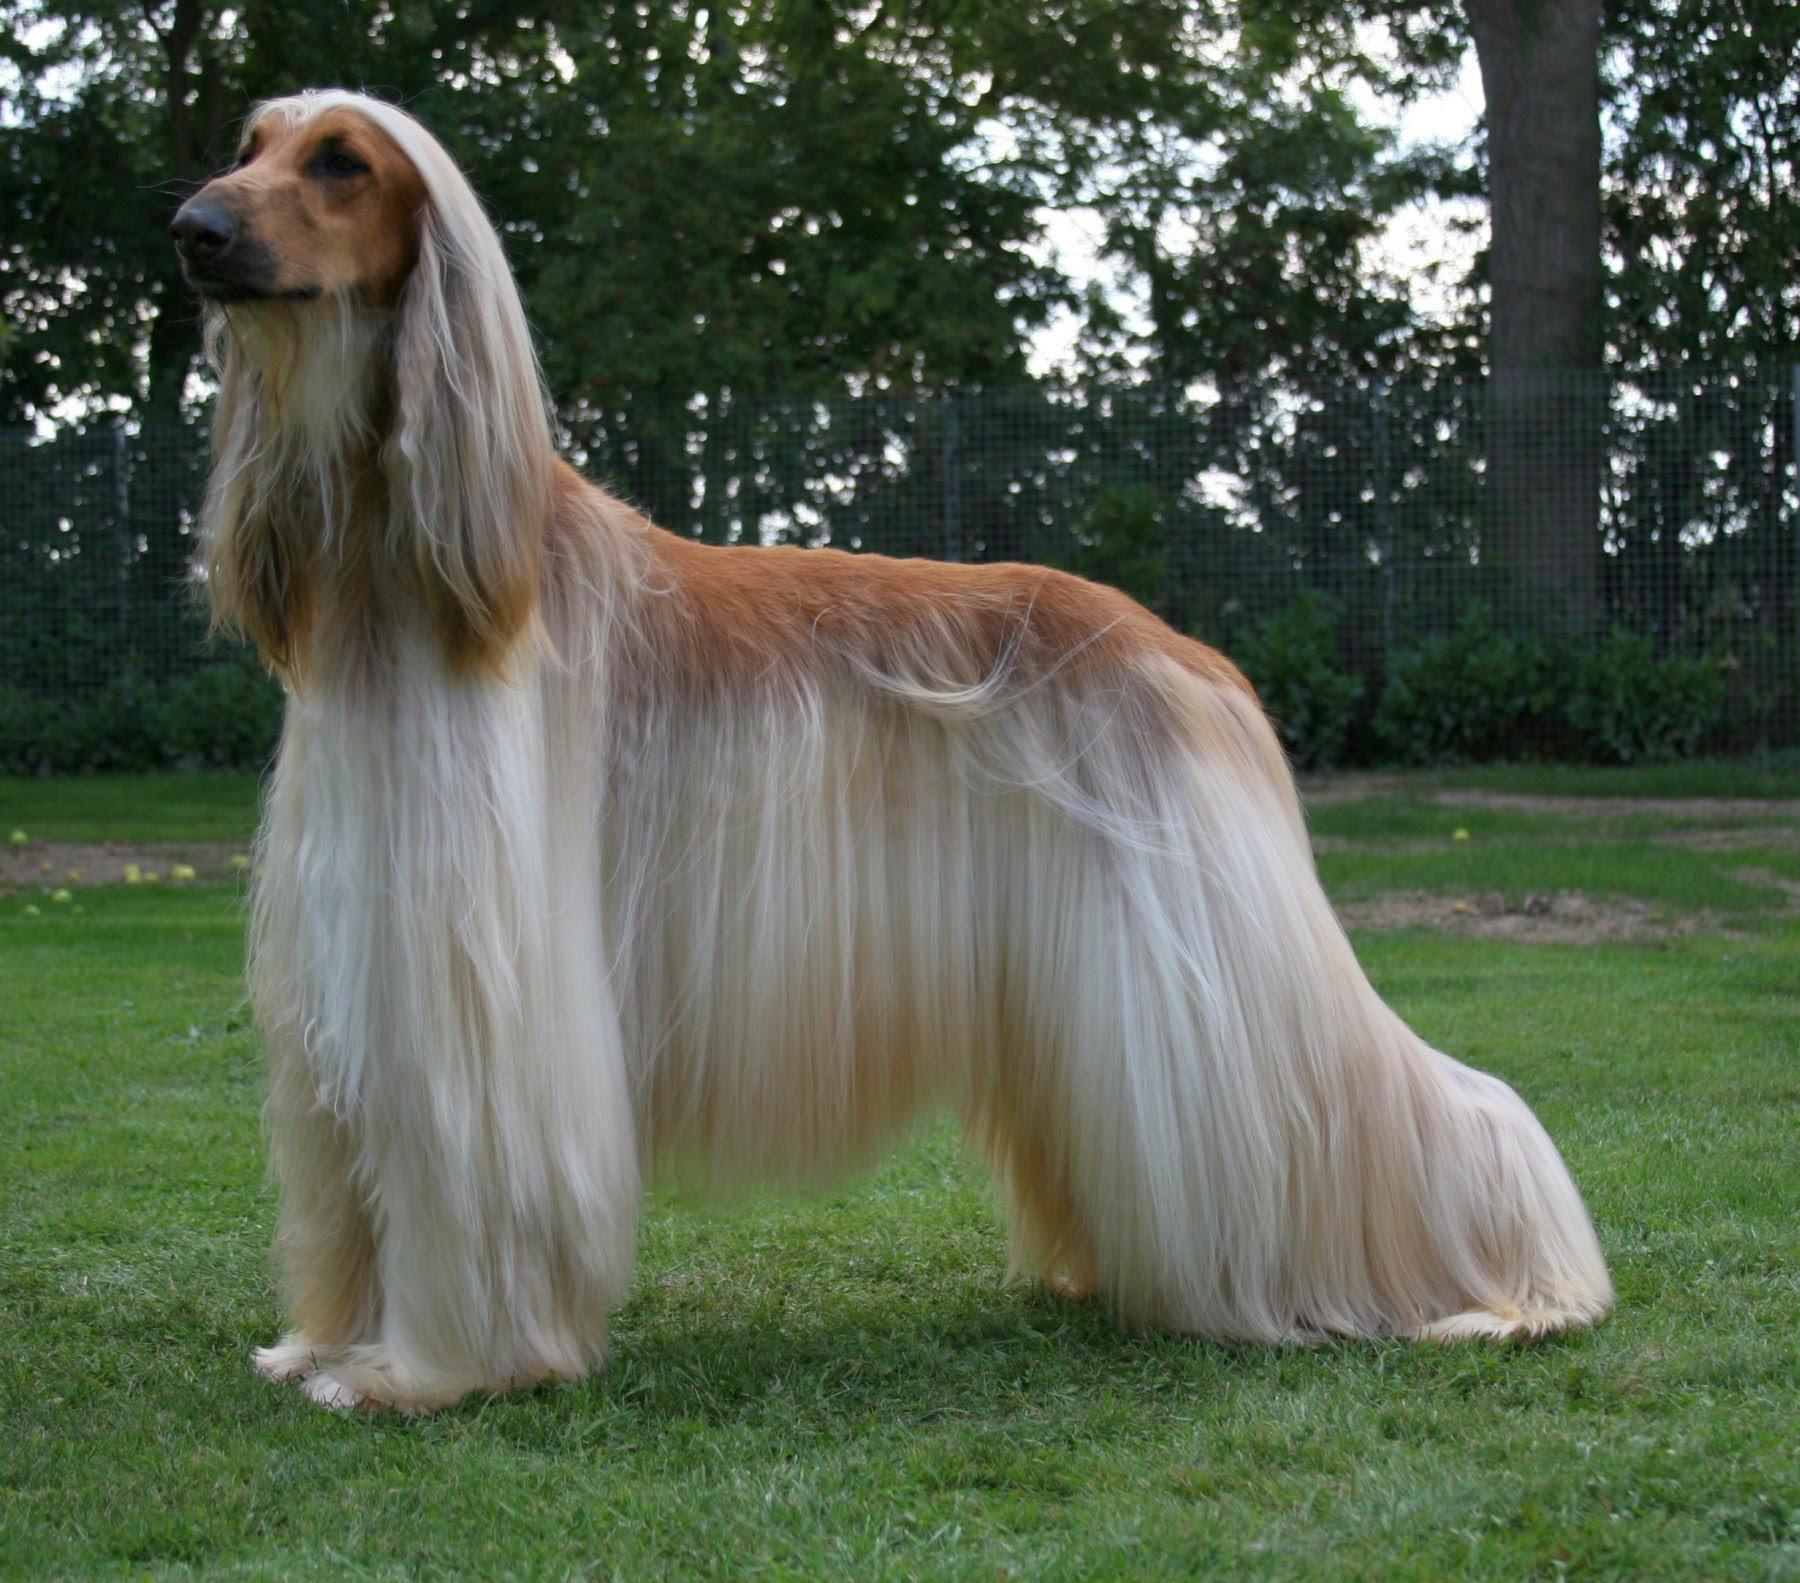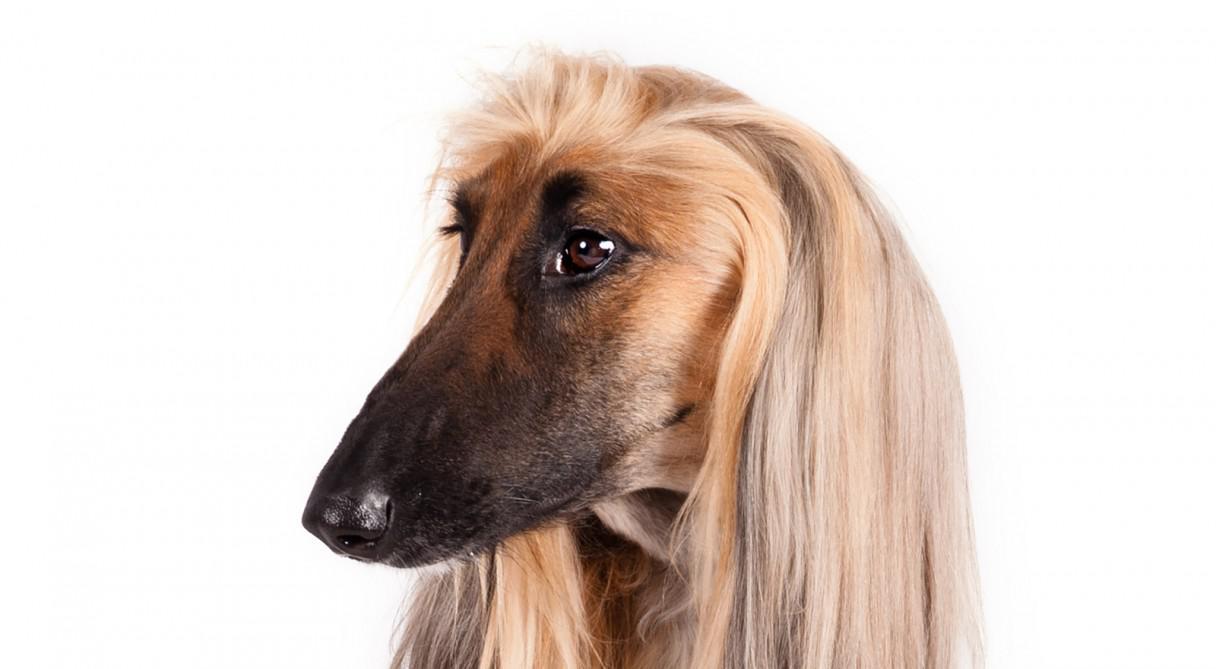The first image is the image on the left, the second image is the image on the right. Analyze the images presented: Is the assertion "The afghan hound in the left image is looking at the camera as the picture is taken." valid? Answer yes or no. No. 